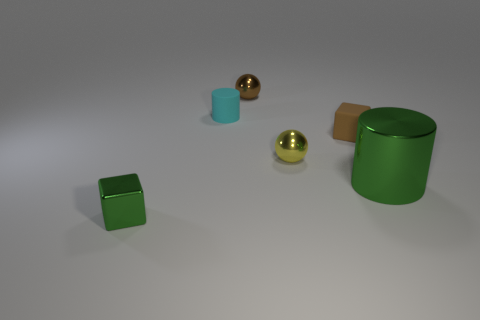What number of things are small yellow spheres or large green cylinders?
Your response must be concise. 2. What size is the shiny object that is the same color as the shiny cube?
Your answer should be compact. Large. There is a brown cube; are there any tiny cylinders in front of it?
Ensure brevity in your answer.  No. Is the number of small cyan matte things that are on the left side of the cyan cylinder greater than the number of brown matte things that are to the left of the green metal cube?
Your answer should be very brief. No. There is a matte thing that is the same shape as the tiny green shiny object; what size is it?
Offer a very short reply. Small. How many balls are either brown rubber things or small green metal objects?
Your response must be concise. 0. What material is the small object that is the same color as the big cylinder?
Ensure brevity in your answer.  Metal. Are there fewer tiny rubber things behind the rubber block than objects that are in front of the small green thing?
Your answer should be very brief. No. How many things are tiny shiny objects on the left side of the yellow metallic thing or tiny brown matte objects?
Offer a very short reply. 3. The small object that is in front of the big green object that is behind the green cube is what shape?
Give a very brief answer. Cube. 